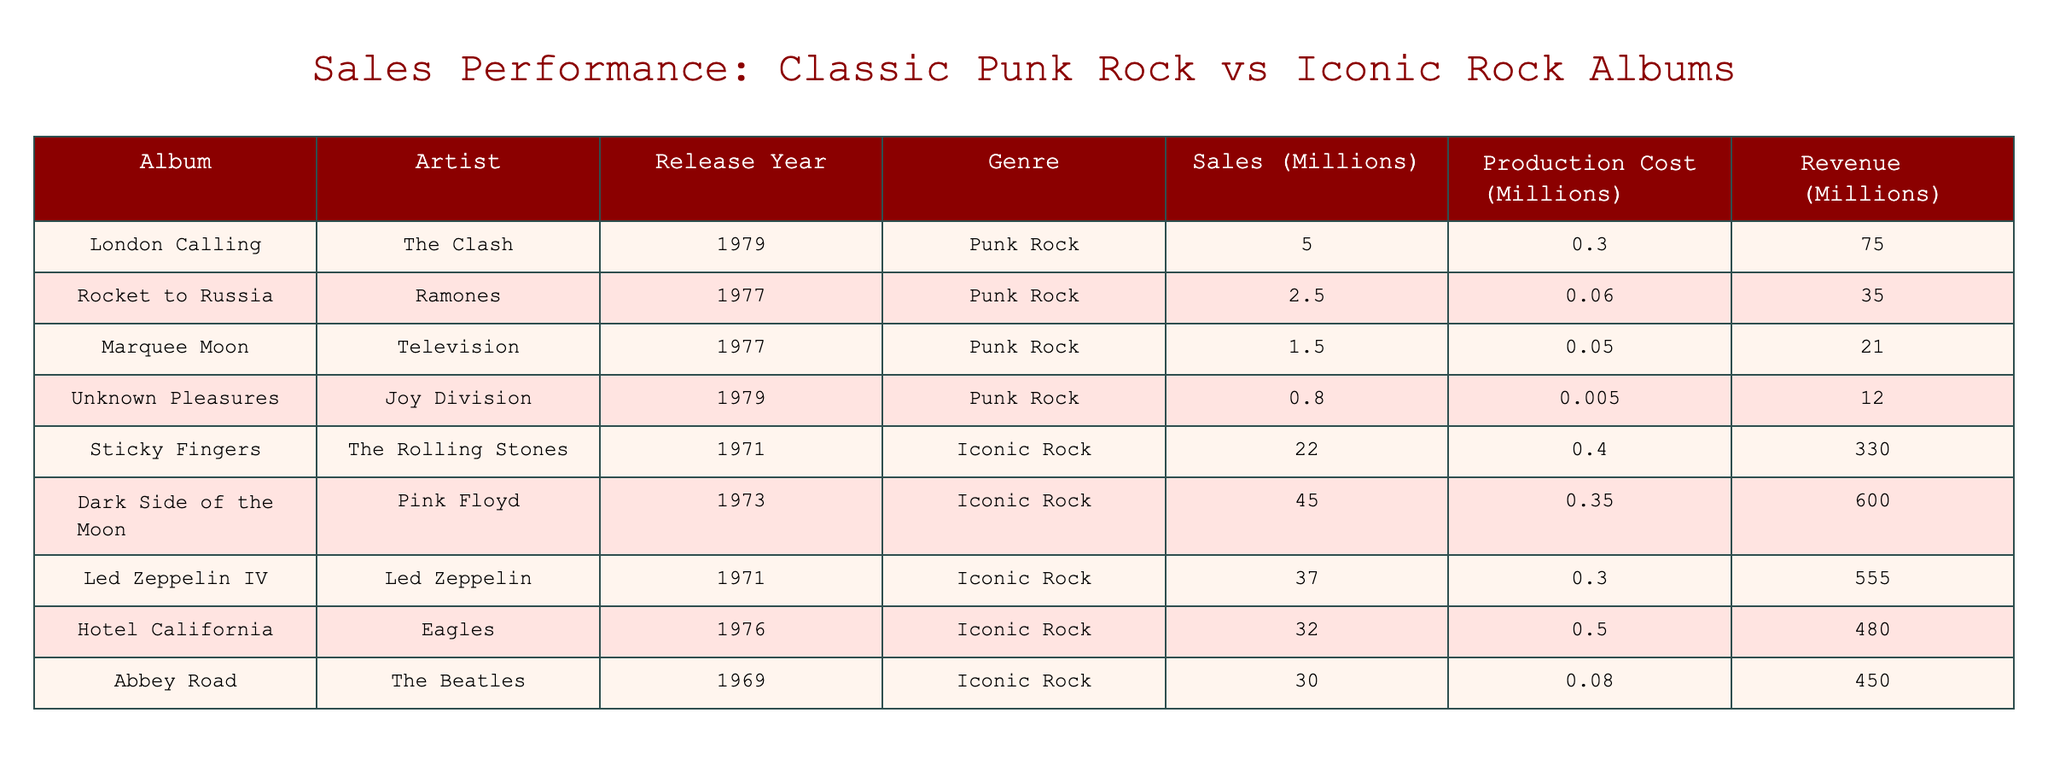What is the total sales for all punk rock albums listed in the table? To find the total sales for the punk rock albums, we add the sales figures for each album: 5 + 2.5 + 1.5 + 0.8 = 9.8 million.
Answer: 9.8 million Which iconic rock album has the highest sales? By comparing the sales figures, "Dark Side of the Moon" has the highest sales at 45 million.
Answer: Dark Side of the Moon How much did "London Calling" generate in revenue compared to its production cost? The revenue for "London Calling" is 75 million, and the production cost is 0.3 million. The revenue is significantly higher than the production cost, indicating a successful album.
Answer: Yes What is the average sales figure for the iconic rock albums? To find the average, we first sum the sales: 22 + 45 + 37 + 32 + 30 = 166 million. There are 5 iconic rock albums, so we divide 166 by 5, which equals 33.2 million.
Answer: 33.2 million Did any punk rock album earn more revenue than any iconic rock album? Comparing the highest revenue from punk rock, which is 75 million for "London Calling", to all iconic rock albums, 75 million is less than the revenue of all listed iconic albums, where the lowest being 330 million.
Answer: No What is the difference in sales between the best-performing punk rock album and the best-performing iconic rock album? The highest-selling punk rock album is "London Calling" at 5 million, and the highest-selling iconic rock album is "Dark Side of the Moon" at 45 million. The difference is 45 - 5 = 40 million.
Answer: 40 million Which album has the lowest production cost and what is that cost? By inspecting the table, "Unknown Pleasures" has the lowest production cost at 0.005 million, making it the lowest in production cost among all albums listed.
Answer: 0.005 million What is the total revenue generated by all the iconic rock albums combined? To calculate the total revenue for iconic rock albums, we sum their revenues: 330 + 600 + 555 + 480 + 450 = 2415 million.
Answer: 2415 million Is the sales to production cost ratio higher for punk rock albums compared to iconic rock albums? To find this, we calculate the ratios. For "London Calling", ratio is 5 / 0.3 = 16.67. For "Dark Side of the Moon", ratio is 45 / 0.35 = 128.57. The punk rock ratio of 16.67 is lower than iconic rock's 128.57.
Answer: No 